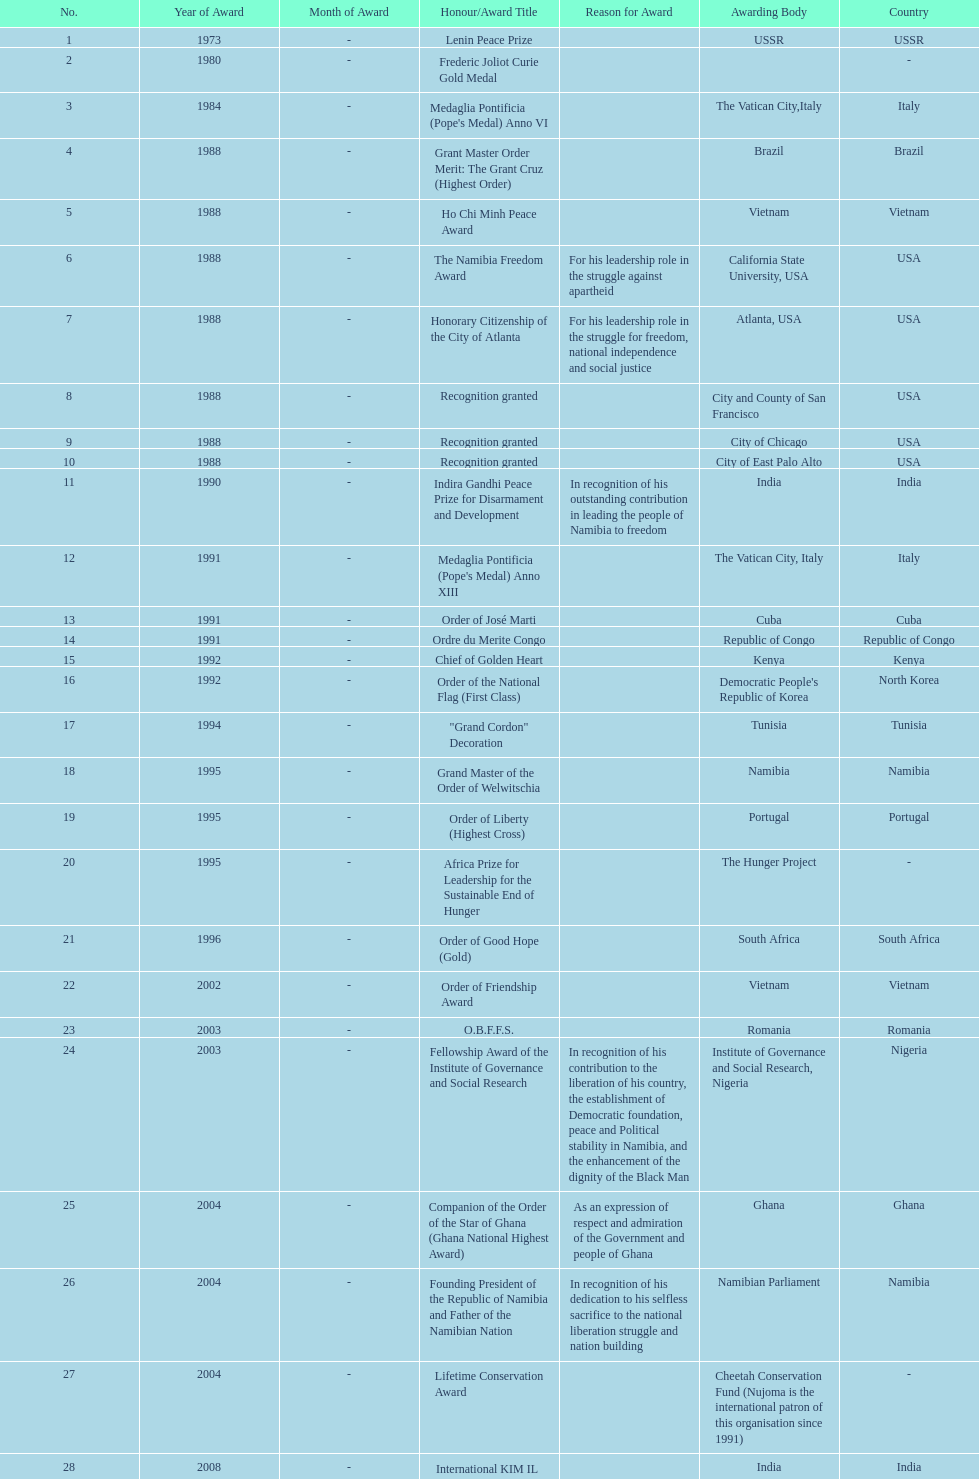What is the most recent award nujoma received? Sir Seretse Khama SADC Meda. 